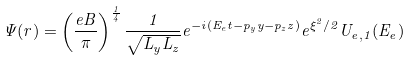Convert formula to latex. <formula><loc_0><loc_0><loc_500><loc_500>\Psi ( r ) = \left ( \frac { e B } { \pi } \right ) ^ { \frac { 1 } { 4 } } \frac { 1 } { \sqrt { L _ { y } L _ { z } } } e ^ { - i ( E _ { e } t - p _ { y } y - p _ { z } z ) } e ^ { \xi ^ { 2 } / 2 } U _ { e , 1 } ( E _ { e } )</formula> 